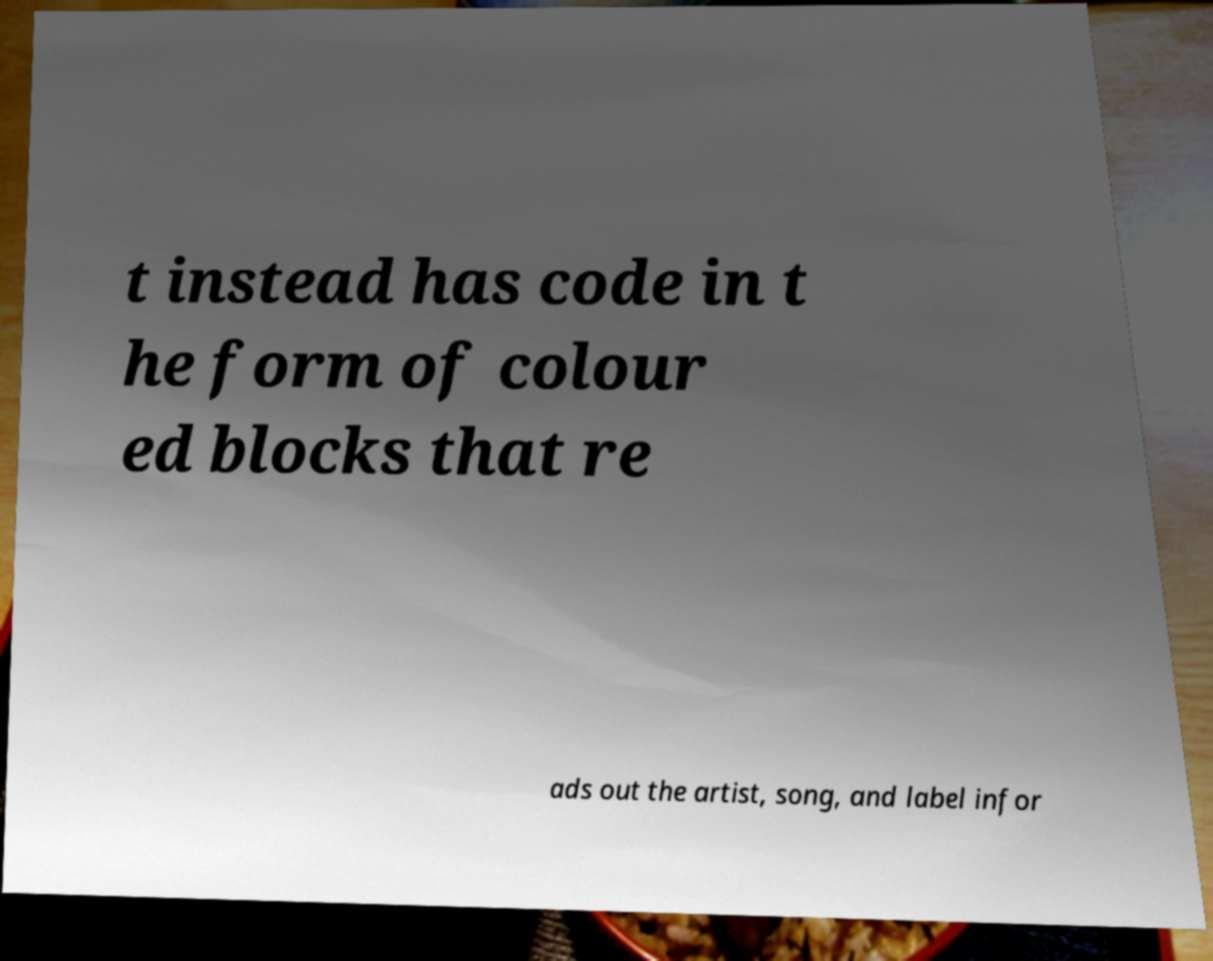Please identify and transcribe the text found in this image. t instead has code in t he form of colour ed blocks that re ads out the artist, song, and label infor 